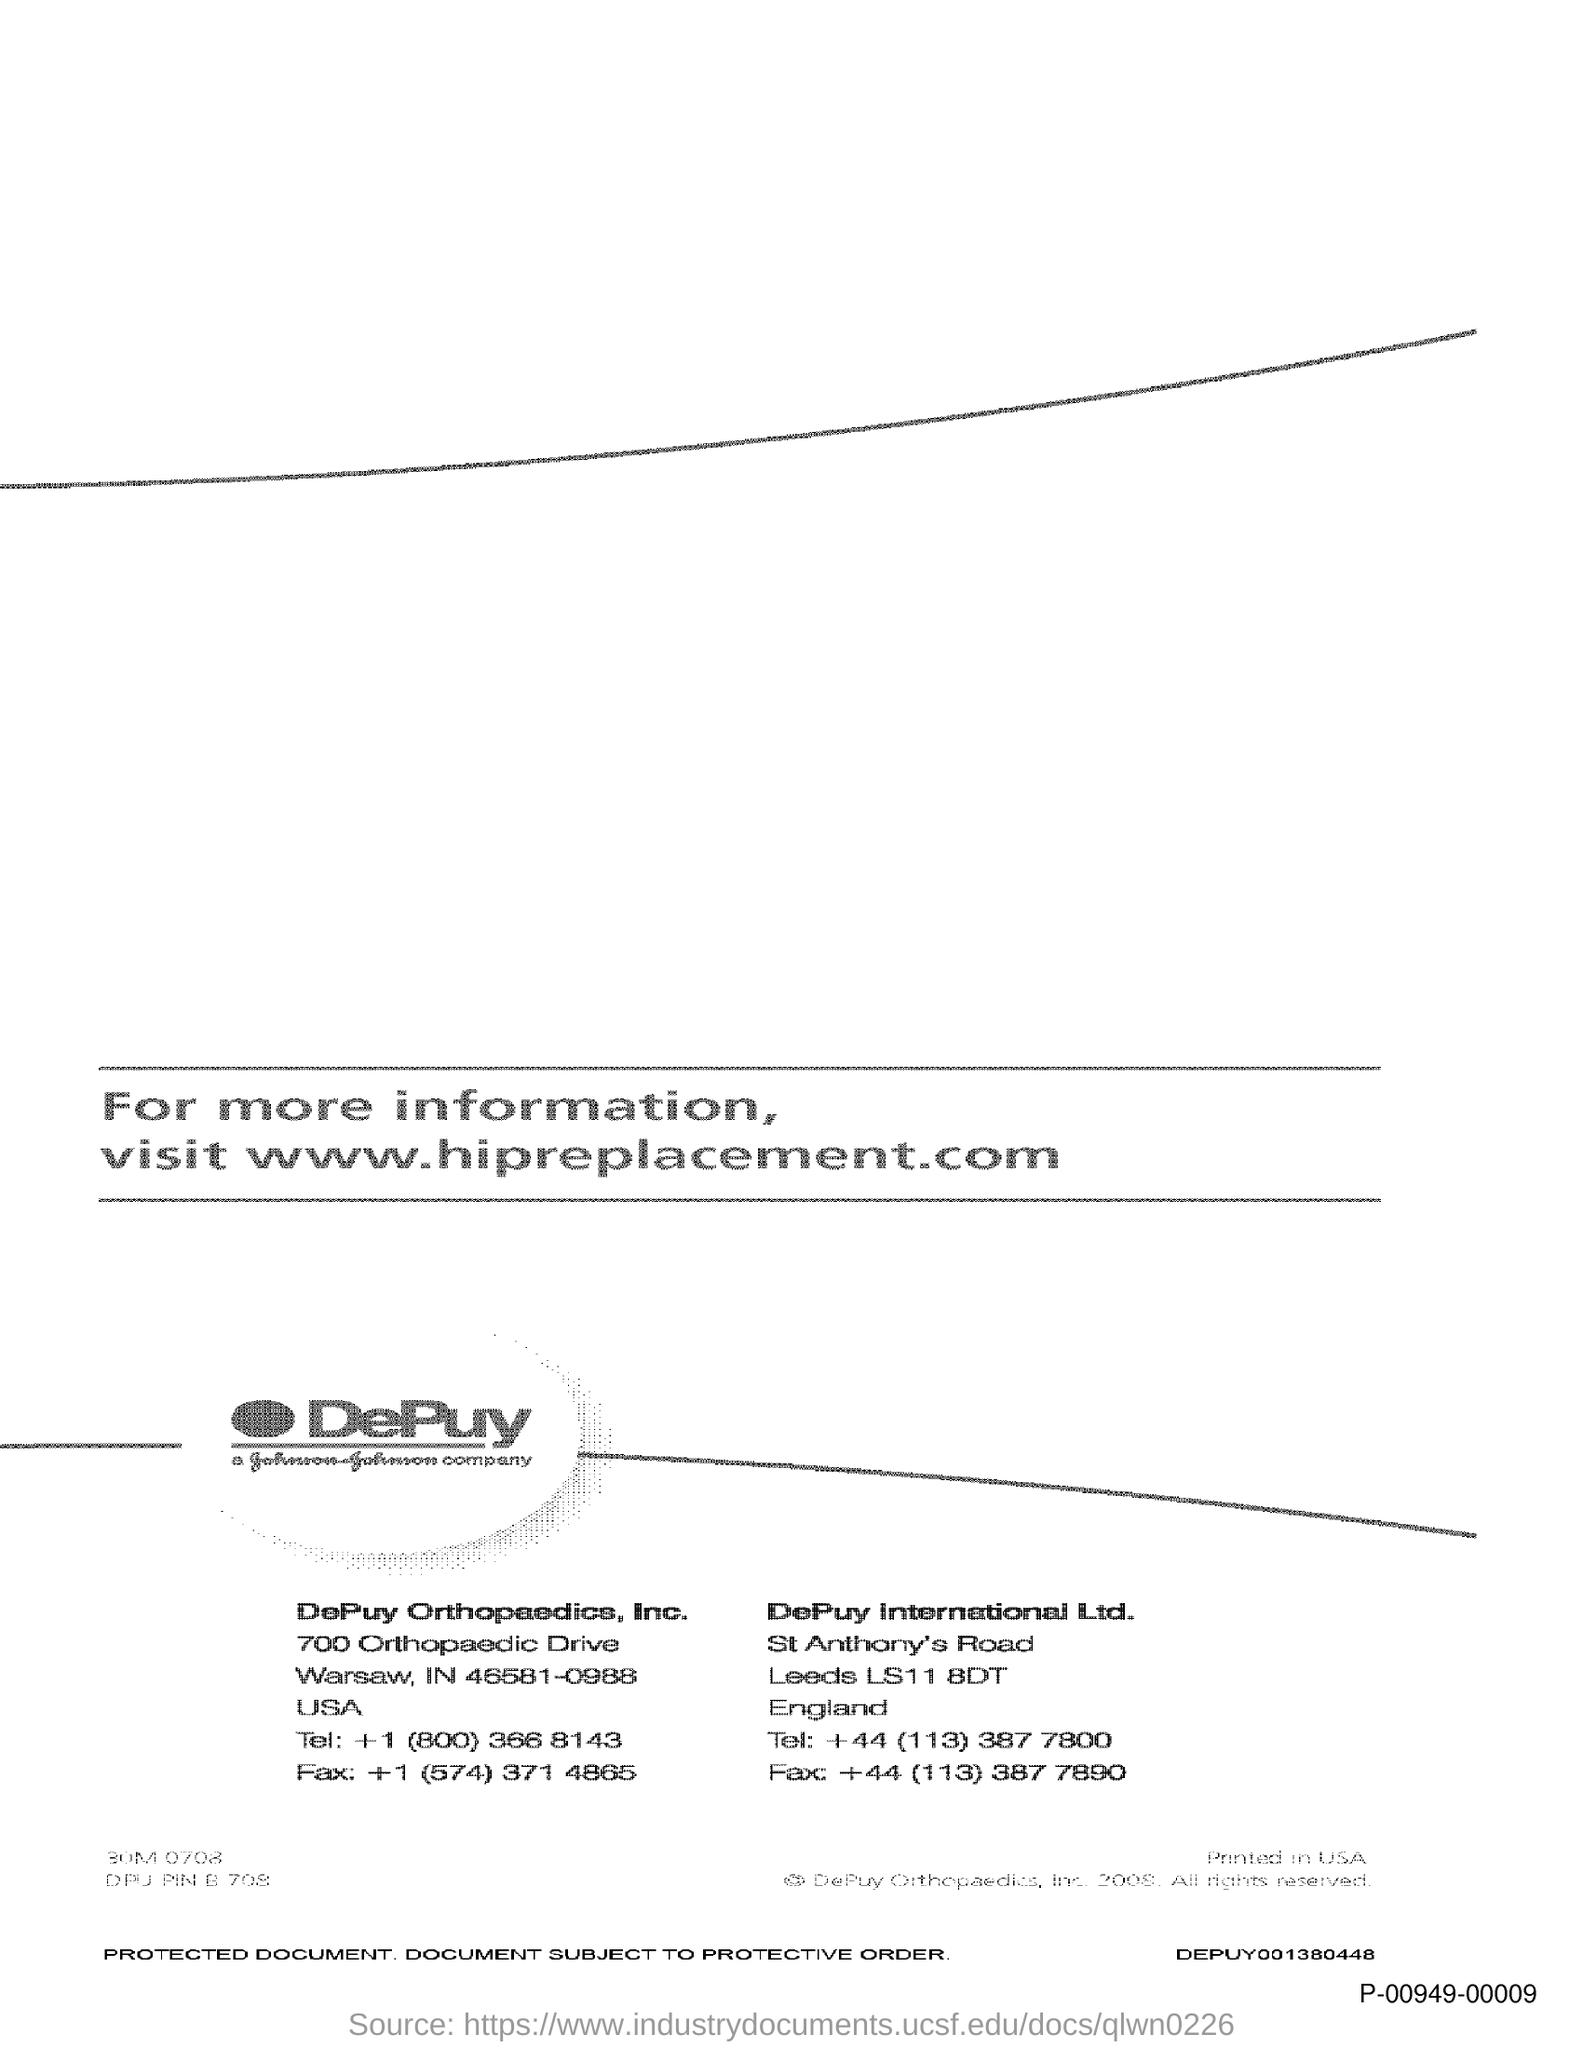What is the Fax for DePuy Orthopaedics, Inc?
Your response must be concise. +1 (574) 371 4865. What is the Fax for DePuy International Ltd?
Your response must be concise. +44 (113) 387 7890. 